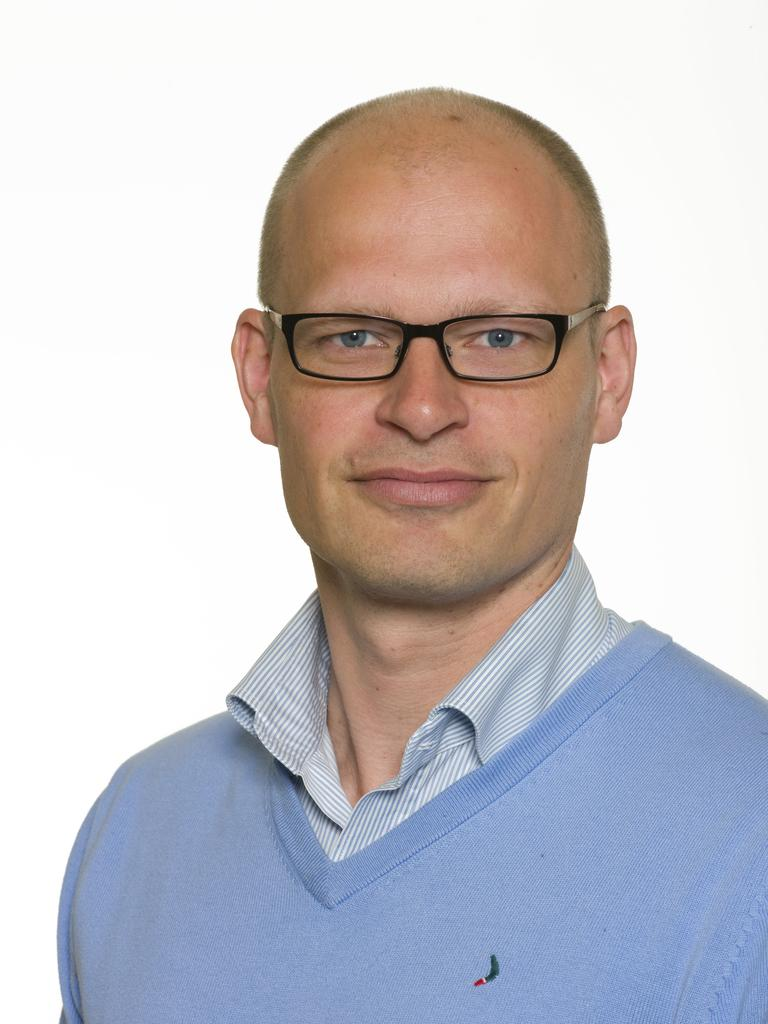Who is present in the image? There is a man in the image. What is the man wearing on his upper body? The man is wearing a blue t-shirt. What accessory is the man wearing on his face? The man is wearing spectacles. What color is the background of the image? The background of the image is white. What type of reaction does the man have to the ball in the crate? There is no ball or crate present in the image, so it is not possible to determine the man's reaction to them. 